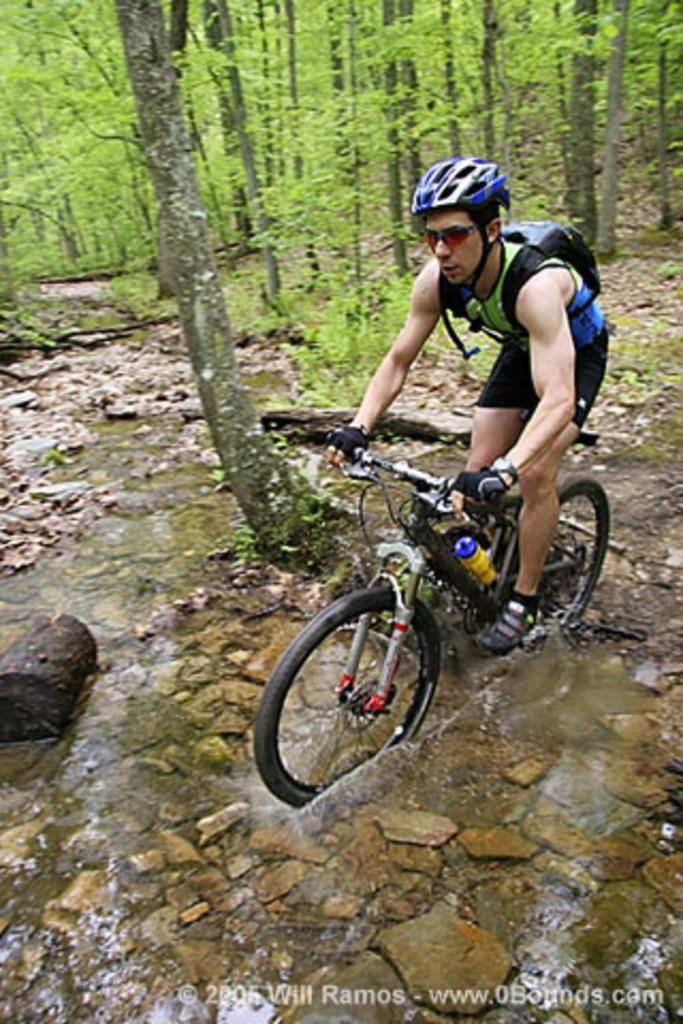Who is present in the image? There is a man in the image. What is the man doing in the image? The man is riding a cycle in the image. Where is the man riding the cycle? The setting is a forest. What can be observed about the forest in the image? There are many tall trees in the forest. What type of stocking is the man wearing while riding the cycle in the image? There is no mention of stockings in the image, so it cannot be determined if the man is wearing any. 